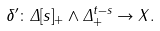Convert formula to latex. <formula><loc_0><loc_0><loc_500><loc_500>\delta ^ { \prime } \colon \Delta [ s ] _ { + } \wedge \Delta ^ { t - s } _ { + } \rightarrow X .</formula> 